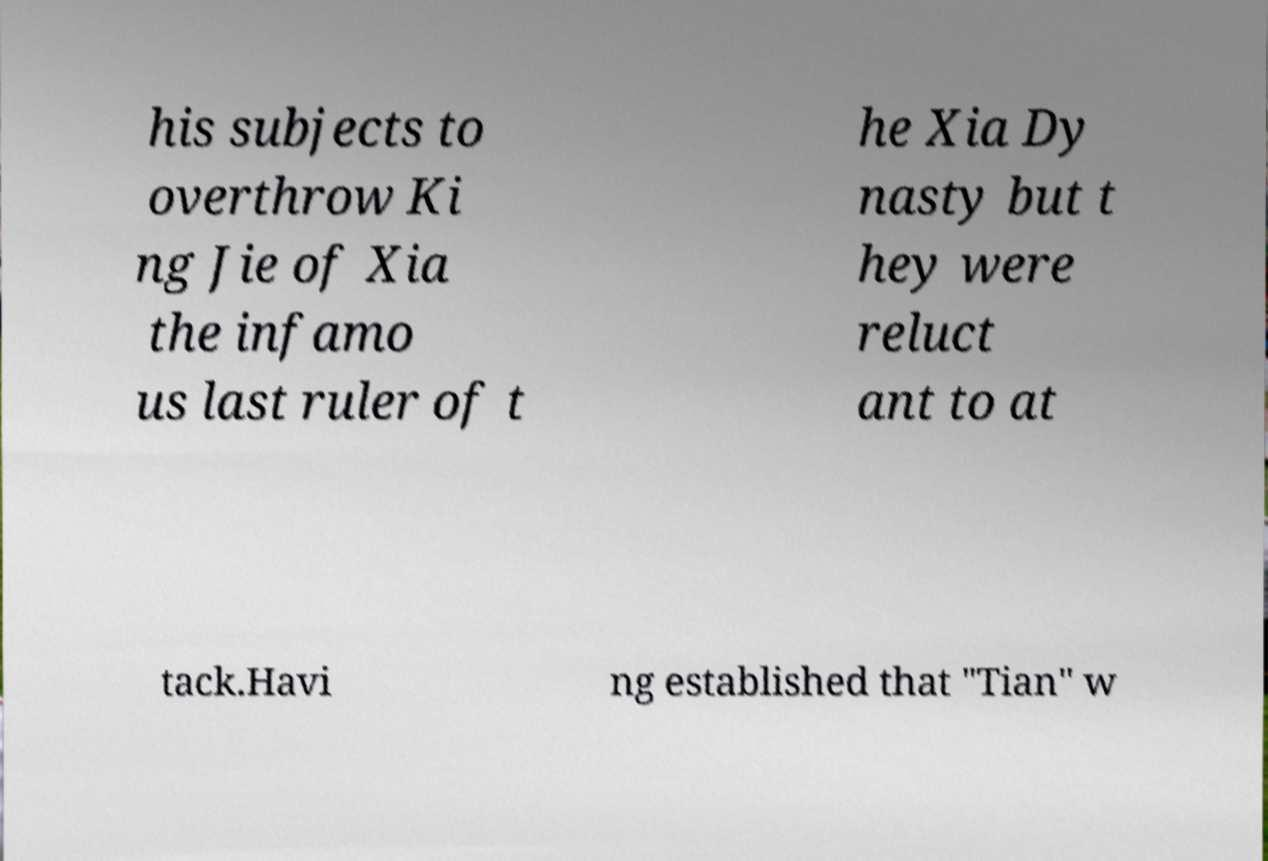There's text embedded in this image that I need extracted. Can you transcribe it verbatim? his subjects to overthrow Ki ng Jie of Xia the infamo us last ruler of t he Xia Dy nasty but t hey were reluct ant to at tack.Havi ng established that "Tian" w 